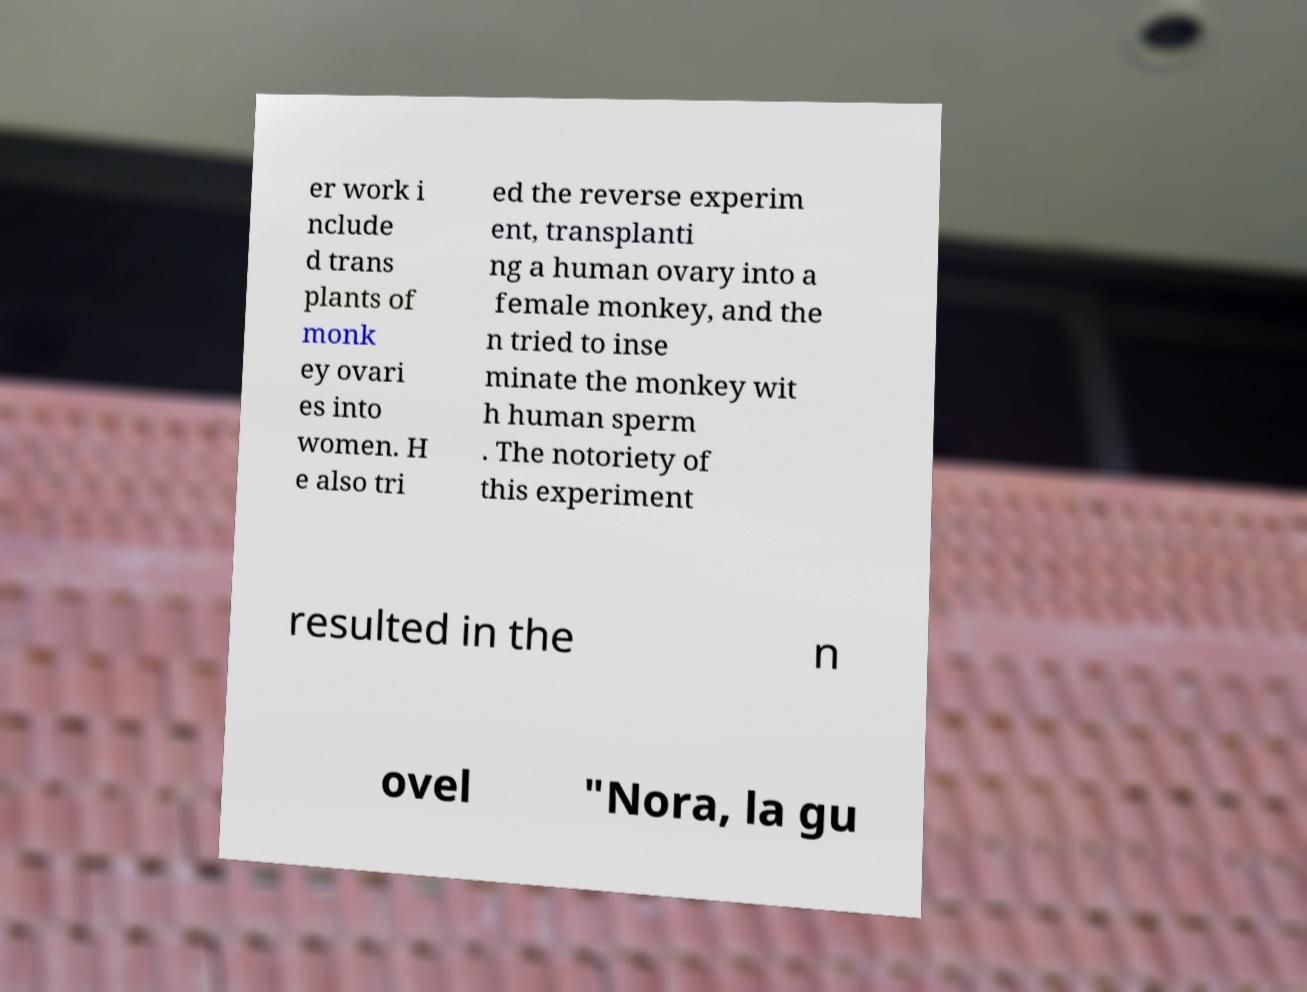For documentation purposes, I need the text within this image transcribed. Could you provide that? er work i nclude d trans plants of monk ey ovari es into women. H e also tri ed the reverse experim ent, transplanti ng a human ovary into a female monkey, and the n tried to inse minate the monkey wit h human sperm . The notoriety of this experiment resulted in the n ovel "Nora, la gu 